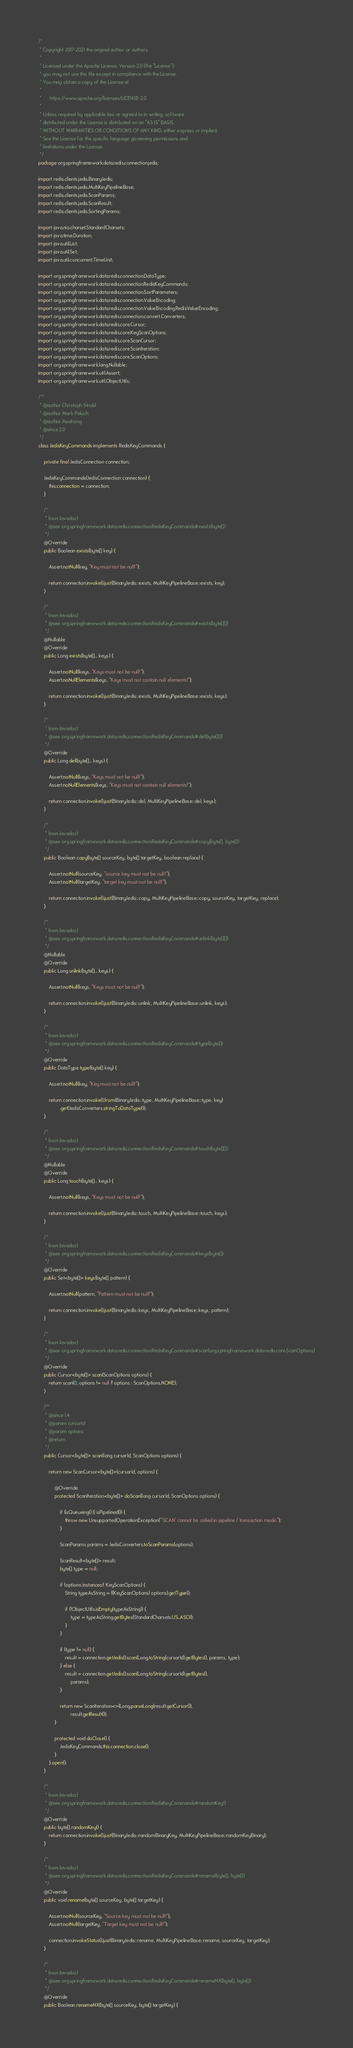Convert code to text. <code><loc_0><loc_0><loc_500><loc_500><_Java_>/*
 * Copyright 2017-2021 the original author or authors.
 *
 * Licensed under the Apache License, Version 2.0 (the "License");
 * you may not use this file except in compliance with the License.
 * You may obtain a copy of the License at
 *
 *      https://www.apache.org/licenses/LICENSE-2.0
 *
 * Unless required by applicable law or agreed to in writing, software
 * distributed under the License is distributed on an "AS IS" BASIS,
 * WITHOUT WARRANTIES OR CONDITIONS OF ANY KIND, either express or implied.
 * See the License for the specific language governing permissions and
 * limitations under the License.
 */
package org.springframework.data.redis.connection.jedis;

import redis.clients.jedis.BinaryJedis;
import redis.clients.jedis.MultiKeyPipelineBase;
import redis.clients.jedis.ScanParams;
import redis.clients.jedis.ScanResult;
import redis.clients.jedis.SortingParams;

import java.nio.charset.StandardCharsets;
import java.time.Duration;
import java.util.List;
import java.util.Set;
import java.util.concurrent.TimeUnit;

import org.springframework.data.redis.connection.DataType;
import org.springframework.data.redis.connection.RedisKeyCommands;
import org.springframework.data.redis.connection.SortParameters;
import org.springframework.data.redis.connection.ValueEncoding;
import org.springframework.data.redis.connection.ValueEncoding.RedisValueEncoding;
import org.springframework.data.redis.connection.convert.Converters;
import org.springframework.data.redis.core.Cursor;
import org.springframework.data.redis.core.KeyScanOptions;
import org.springframework.data.redis.core.ScanCursor;
import org.springframework.data.redis.core.ScanIteration;
import org.springframework.data.redis.core.ScanOptions;
import org.springframework.lang.Nullable;
import org.springframework.util.Assert;
import org.springframework.util.ObjectUtils;

/**
 * @author Christoph Strobl
 * @author Mark Paluch
 * @author ihaohong
 * @since 2.0
 */
class JedisKeyCommands implements RedisKeyCommands {

	private final JedisConnection connection;

	JedisKeyCommands(JedisConnection connection) {
		this.connection = connection;
	}

	/*
	 * (non-Javadoc)
	 * @see org.springframework.data.redis.connection.RedisKeyCommands#exists(byte[])
	 */
	@Override
	public Boolean exists(byte[] key) {

		Assert.notNull(key, "Key must not be null!");

		return connection.invoke().just(BinaryJedis::exists, MultiKeyPipelineBase::exists, key);
	}

	/*
	 * (non-Javadoc)
	 * @see org.springframework.data.redis.connection.RedisKeyCommands#exists(byte[][])
	 */
	@Nullable
	@Override
	public Long exists(byte[]... keys) {

		Assert.notNull(keys, "Keys must not be null!");
		Assert.noNullElements(keys, "Keys must not contain null elements!");

		return connection.invoke().just(BinaryJedis::exists, MultiKeyPipelineBase::exists, keys);
	}

	/*
	 * (non-Javadoc)
	 * @see org.springframework.data.redis.connection.RedisKeyCommands#del(byte[][])
	 */
	@Override
	public Long del(byte[]... keys) {

		Assert.notNull(keys, "Keys must not be null!");
		Assert.noNullElements(keys, "Keys must not contain null elements!");

		return connection.invoke().just(BinaryJedis::del, MultiKeyPipelineBase::del, keys);
	}

	/*
	 * (non-Javadoc)
	 * @see org.springframework.data.redis.connection.RedisKeyCommands#copy(byte[], byte[])
	 */
	public Boolean copy(byte[] sourceKey, byte[] targetKey, boolean replace) {

		Assert.notNull(sourceKey, "source key must not be null!");
		Assert.notNull(targetKey, "target key must not be null!");

		return connection.invoke().just(BinaryJedis::copy, MultiKeyPipelineBase::copy, sourceKey, targetKey, replace);
	}

	/*
	 * (non-Javadoc)
	 * @see org.springframework.data.redis.connection.RedisKeyCommands#unlink(byte[][])
	 */
	@Nullable
	@Override
	public Long unlink(byte[]... keys) {

		Assert.notNull(keys, "Keys must not be null!");

		return connection.invoke().just(BinaryJedis::unlink, MultiKeyPipelineBase::unlink, keys);
	}

	/*
	 * (non-Javadoc)
	 * @see org.springframework.data.redis.connection.RedisKeyCommands#type(byte[])
	 */
	@Override
	public DataType type(byte[] key) {

		Assert.notNull(key, "Key must not be null!");

		return connection.invoke().from(BinaryJedis::type, MultiKeyPipelineBase::type, key)
				.get(JedisConverters.stringToDataType());
	}

	/*
	 * (non-Javadoc)
	 * @see org.springframework.data.redis.connection.RedisKeyCommands#touch(byte[][])
	 */
	@Nullable
	@Override
	public Long touch(byte[]... keys) {

		Assert.notNull(keys, "Keys must not be null!");

		return connection.invoke().just(BinaryJedis::touch, MultiKeyPipelineBase::touch, keys);
	}

	/*
	 * (non-Javadoc)
	 * @see org.springframework.data.redis.connection.RedisKeyCommands#keys(byte[])
	 */
	@Override
	public Set<byte[]> keys(byte[] pattern) {

		Assert.notNull(pattern, "Pattern must not be null!");

		return connection.invoke().just(BinaryJedis::keys, MultiKeyPipelineBase::keys, pattern);
	}

	/*
	 * (non-Javadoc)
	 * @see org.springframework.data.redis.connection.RedisKeyCommands#scan(org.springframework.data.redis.core.ScanOptions)
	 */
	@Override
	public Cursor<byte[]> scan(ScanOptions options) {
		return scan(0, options != null ? options : ScanOptions.NONE);
	}

	/**
	 * @since 1.4
	 * @param cursorId
	 * @param options
	 * @return
	 */
	public Cursor<byte[]> scan(long cursorId, ScanOptions options) {

		return new ScanCursor<byte[]>(cursorId, options) {

			@Override
			protected ScanIteration<byte[]> doScan(long cursorId, ScanOptions options) {

				if (isQueueing() || isPipelined()) {
					throw new UnsupportedOperationException("'SCAN' cannot be called in pipeline / transaction mode.");
				}

				ScanParams params = JedisConverters.toScanParams(options);

				ScanResult<byte[]> result;
				byte[] type = null;

				if (options instanceof KeyScanOptions) {
					String typeAsString = ((KeyScanOptions) options).getType();

					if (!ObjectUtils.isEmpty(typeAsString)) {
						type = typeAsString.getBytes(StandardCharsets.US_ASCII);
					}
				}

				if (type != null) {
					result = connection.getJedis().scan(Long.toString(cursorId).getBytes(), params, type);
				} else {
					result = connection.getJedis().scan(Long.toString(cursorId).getBytes(),
						params);
				}

				return new ScanIteration<>(Long.parseLong(result.getCursor()),
						result.getResult());
			}

			protected void doClose() {
				JedisKeyCommands.this.connection.close();
			}
		}.open();
	}

	/*
	 * (non-Javadoc)
	 * @see org.springframework.data.redis.connection.RedisKeyCommands#randomKey()
	 */
	@Override
	public byte[] randomKey() {
		return connection.invoke().just(BinaryJedis::randomBinaryKey, MultiKeyPipelineBase::randomKeyBinary);
	}

	/*
	 * (non-Javadoc)
	 * @see org.springframework.data.redis.connection.RedisKeyCommands#rename(byte[], byte[])
	 */
	@Override
	public void rename(byte[] sourceKey, byte[] targetKey) {

		Assert.notNull(sourceKey, "Source key must not be null!");
		Assert.notNull(targetKey, "Target key must not be null!");

		connection.invokeStatus().just(BinaryJedis::rename, MultiKeyPipelineBase::rename, sourceKey, targetKey);
	}

	/*
	 * (non-Javadoc)
	 * @see org.springframework.data.redis.connection.RedisKeyCommands#renameNX(byte[], byte[])
	 */
	@Override
	public Boolean renameNX(byte[] sourceKey, byte[] targetKey) {
</code> 